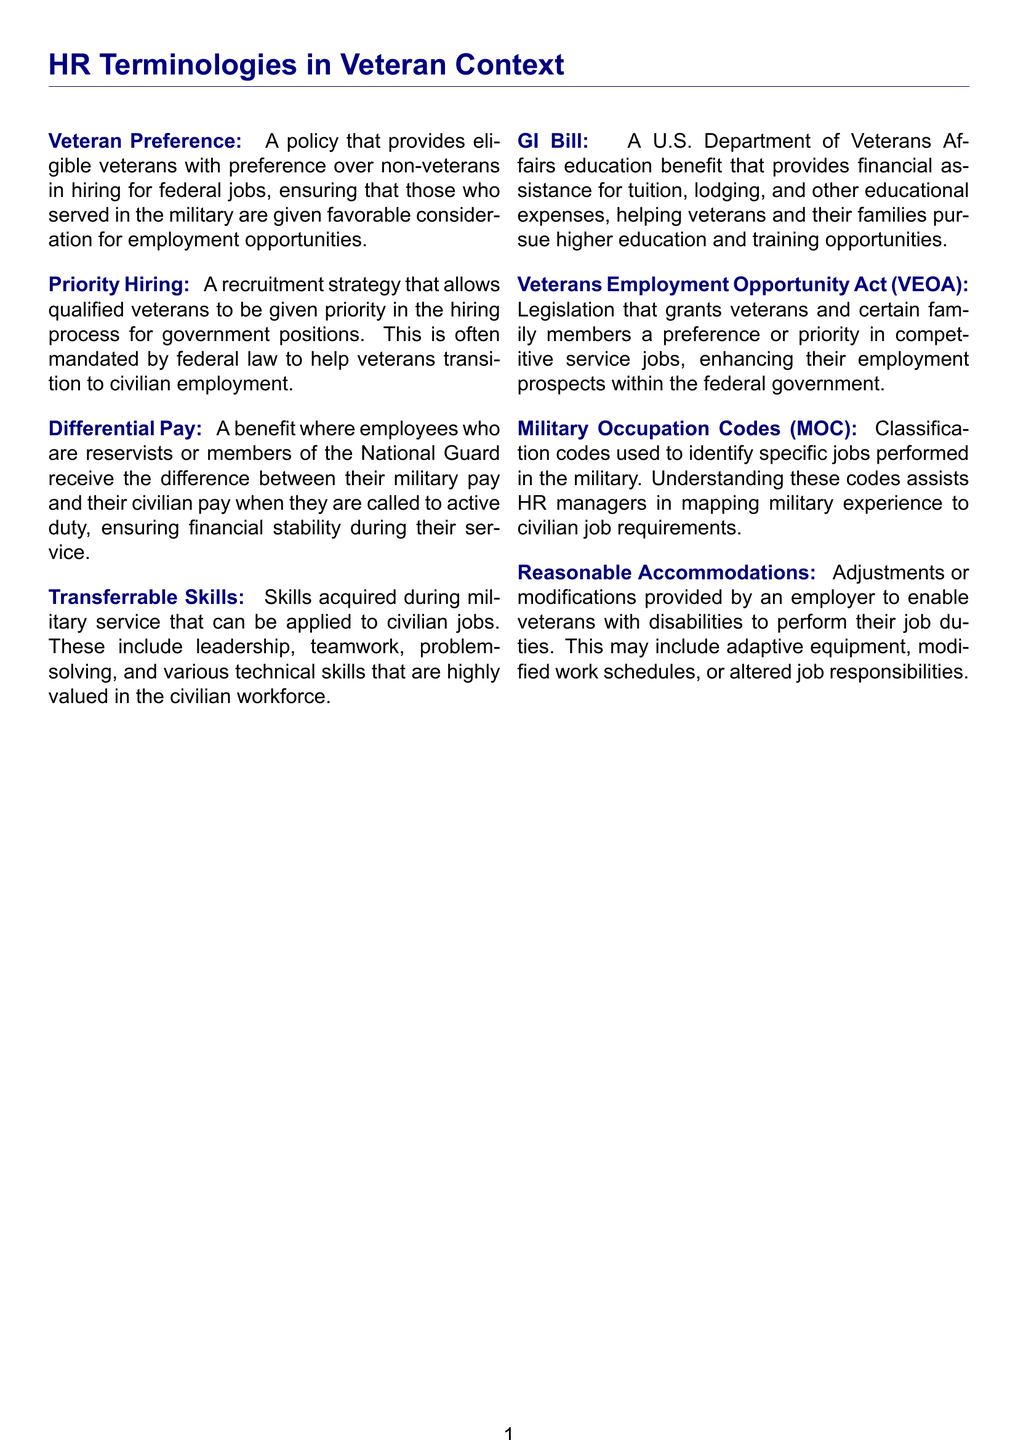What is veteran preference? Veteran preference is a policy that provides eligible veterans with preference over non-veterans in hiring for federal jobs.
Answer: A policy that provides eligible veterans with preference over non-veterans in hiring for federal jobs What does the GI Bill provide? The GI Bill provides financial assistance for tuition, lodging, and other educational expenses.
Answer: Financial assistance for tuition, lodging, and other educational expenses What is the purpose of the Veterans Employment Opportunity Act? The purpose is to grant veterans and certain family members a preference or priority in competitive service jobs.
Answer: To grant veterans and certain family members a preference or priority in competitive service jobs What kind of skills are referred to as transferrable skills? Transferrable skills include leadership, teamwork, problem-solving, and various technical skills.
Answer: Leadership, teamwork, problem-solving, and various technical skills How does priority hiring benefit qualified veterans? Priority hiring allows qualified veterans to be given priority in the hiring process for government positions.
Answer: To be given priority in the hiring process for government positions Why are Military Occupation Codes important for HR managers? Military Occupation Codes are important because they assist HR managers in mapping military experience to civilian job requirements.
Answer: They assist in mapping military experience to civilian job requirements What is reasonable accommodation? Reasonable accommodation includes adjustments or modifications provided by an employer to enable veterans with disabilities to perform their job duties.
Answer: Adjustments or modifications provided by an employer to enable veterans with disabilities to perform their job duties 